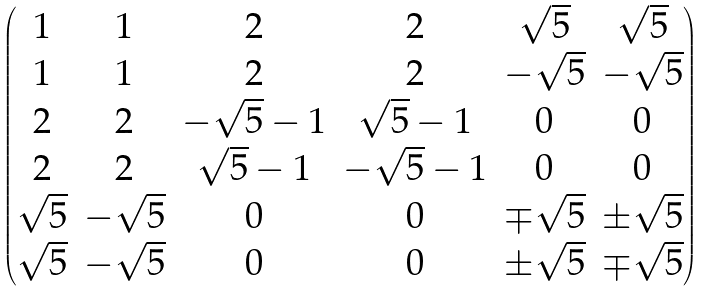<formula> <loc_0><loc_0><loc_500><loc_500>\begin{pmatrix} 1 & 1 & 2 & 2 & \sqrt { 5 } & \sqrt { 5 } \\ 1 & 1 & 2 & 2 & - \sqrt { 5 } & - \sqrt { 5 } \\ 2 & 2 & - \sqrt { 5 } - 1 & \sqrt { 5 } - 1 & 0 & 0 \\ 2 & 2 & \sqrt { 5 } - 1 & - \sqrt { 5 } - 1 & 0 & 0 \\ \sqrt { 5 } & - \sqrt { 5 } & 0 & 0 & \mp \sqrt { 5 } & \pm \sqrt { 5 } \\ \sqrt { 5 } & - \sqrt { 5 } & 0 & 0 & \pm \sqrt { 5 } & \mp \sqrt { 5 } \end{pmatrix}</formula> 